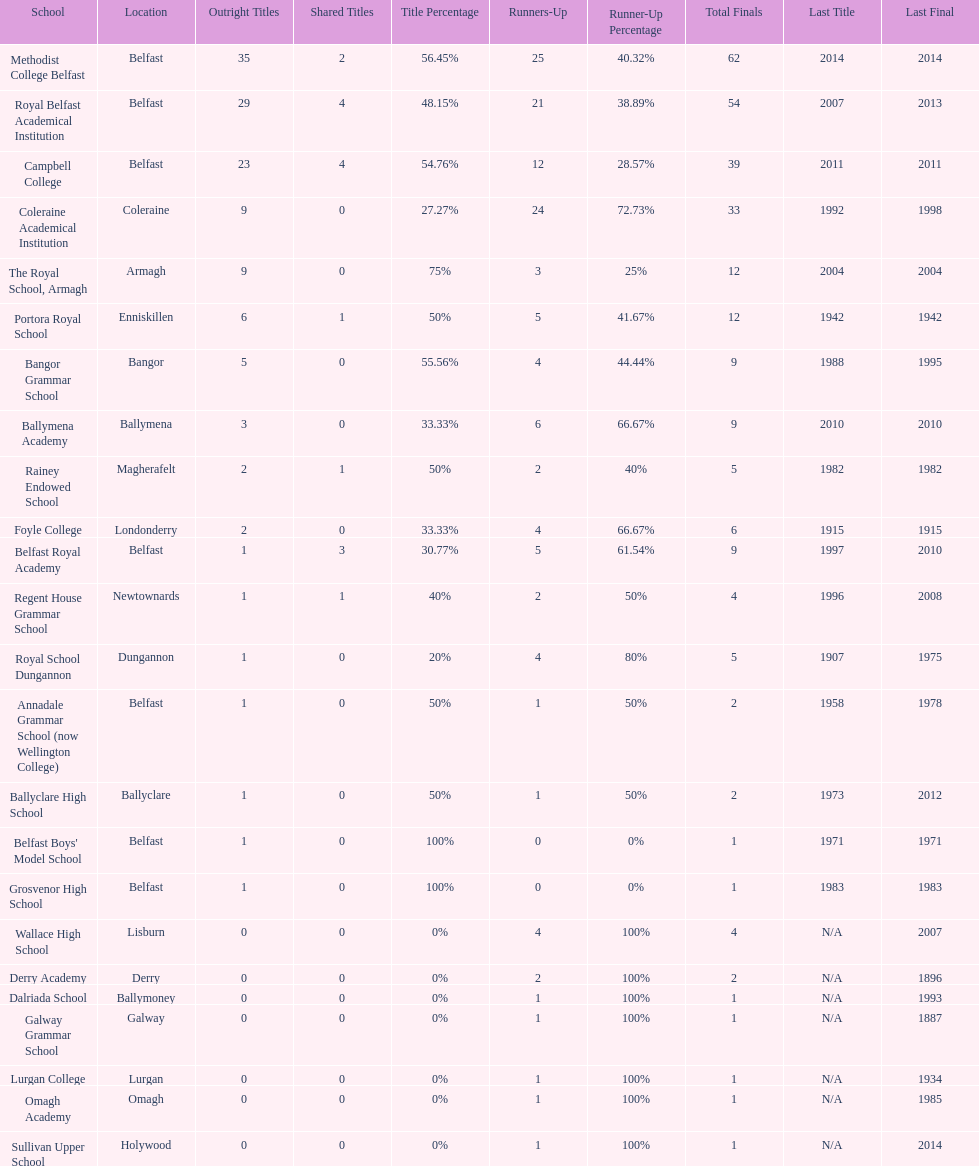Could you parse the entire table as a dict? {'header': ['School', 'Location', 'Outright Titles', 'Shared Titles', 'Title Percentage', 'Runners-Up', 'Runner-Up Percentage', 'Total Finals', 'Last Title', 'Last Final'], 'rows': [['Methodist College Belfast', 'Belfast', '35', '2', '56.45%', '25', '40.32%', '62', '2014', '2014'], ['Royal Belfast Academical Institution', 'Belfast', '29', '4', '48.15%', '21', '38.89%', '54', '2007', '2013'], ['Campbell College', 'Belfast', '23', '4', '54.76%', '12', '28.57%', '39', '2011', '2011'], ['Coleraine Academical Institution', 'Coleraine', '9', '0', '27.27%', '24', '72.73%', '33', '1992', '1998'], ['The Royal School, Armagh', 'Armagh', '9', '0', '75%', '3', '25%', '12', '2004', '2004'], ['Portora Royal School', 'Enniskillen', '6', '1', '50%', '5', '41.67%', '12', '1942', '1942'], ['Bangor Grammar School', 'Bangor', '5', '0', '55.56%', '4', '44.44%', '9', '1988', '1995'], ['Ballymena Academy', 'Ballymena', '3', '0', '33.33%', '6', '66.67%', '9', '2010', '2010'], ['Rainey Endowed School', 'Magherafelt', '2', '1', '50%', '2', '40%', '5', '1982', '1982'], ['Foyle College', 'Londonderry', '2', '0', '33.33%', '4', '66.67%', '6', '1915', '1915'], ['Belfast Royal Academy', 'Belfast', '1', '3', '30.77%', '5', '61.54%', '9', '1997', '2010'], ['Regent House Grammar School', 'Newtownards', '1', '1', '40%', '2', '50%', '4', '1996', '2008'], ['Royal School Dungannon', 'Dungannon', '1', '0', '20%', '4', '80%', '5', '1907', '1975'], ['Annadale Grammar School (now Wellington College)', 'Belfast', '1', '0', '50%', '1', '50%', '2', '1958', '1978'], ['Ballyclare High School', 'Ballyclare', '1', '0', '50%', '1', '50%', '2', '1973', '2012'], ["Belfast Boys' Model School", 'Belfast', '1', '0', '100%', '0', '0%', '1', '1971', '1971'], ['Grosvenor High School', 'Belfast', '1', '0', '100%', '0', '0%', '1', '1983', '1983'], ['Wallace High School', 'Lisburn', '0', '0', '0%', '4', '100%', '4', 'N/A', '2007'], ['Derry Academy', 'Derry', '0', '0', '0%', '2', '100%', '2', 'N/A', '1896'], ['Dalriada School', 'Ballymoney', '0', '0', '0%', '1', '100%', '1', 'N/A', '1993'], ['Galway Grammar School', 'Galway', '0', '0', '0%', '1', '100%', '1', 'N/A', '1887'], ['Lurgan College', 'Lurgan', '0', '0', '0%', '1', '100%', '1', 'N/A', '1934'], ['Omagh Academy', 'Omagh', '0', '0', '0%', '1', '100%', '1', 'N/A', '1985'], ['Sullivan Upper School', 'Holywood', '0', '0', '0%', '1', '100%', '1', 'N/A', '2014']]} Who has the most recent title win, campbell college or regent house grammar school? Campbell College. 